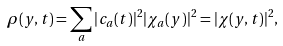Convert formula to latex. <formula><loc_0><loc_0><loc_500><loc_500>\rho ( y , t ) = \sum _ { a } | c _ { a } ( t ) | ^ { 2 } | \chi _ { a } ( y ) | ^ { 2 } = | \chi ( y , t ) | ^ { 2 } ,</formula> 